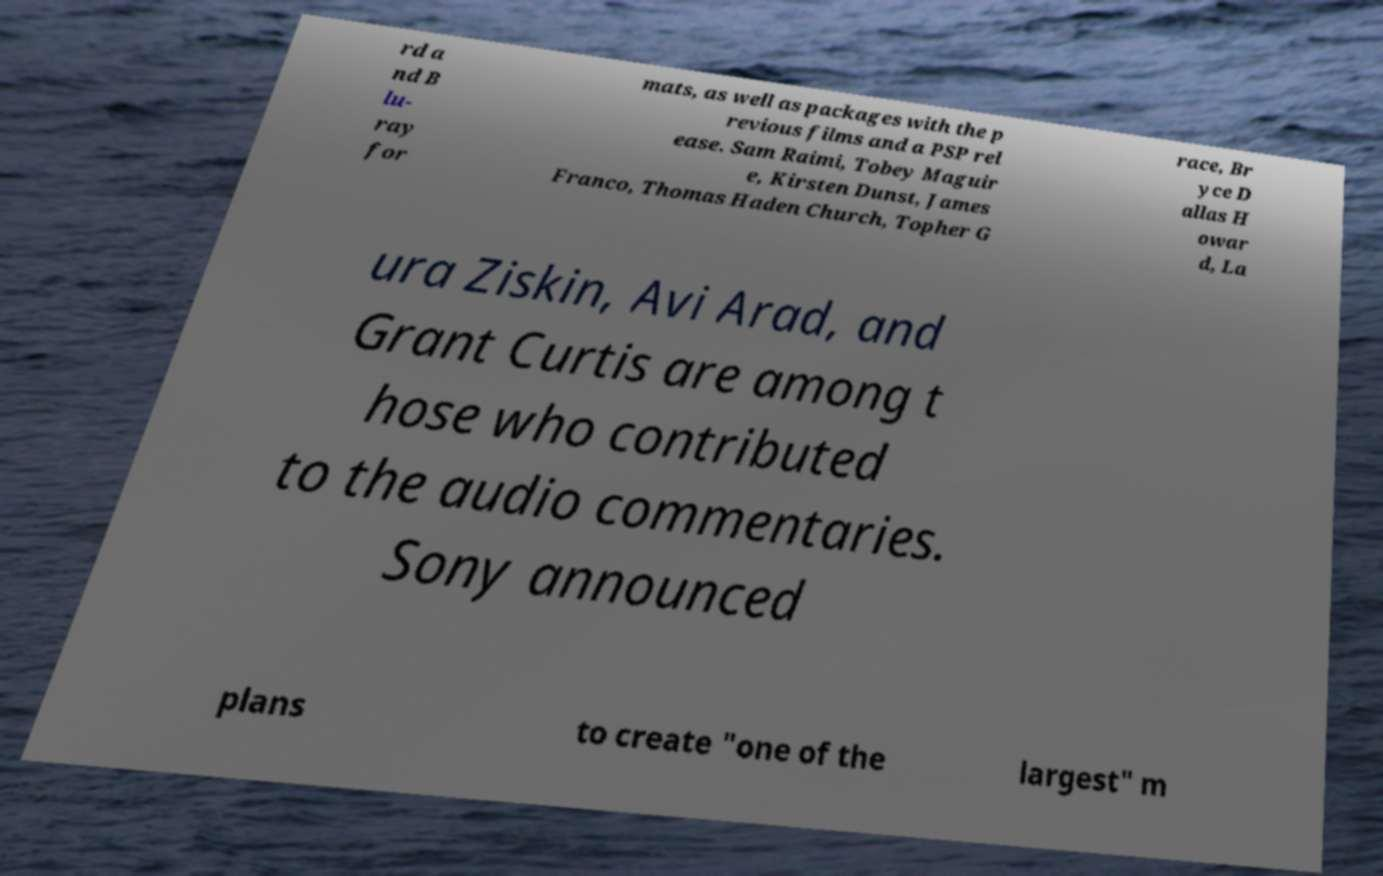Please read and relay the text visible in this image. What does it say? rd a nd B lu- ray for mats, as well as packages with the p revious films and a PSP rel ease. Sam Raimi, Tobey Maguir e, Kirsten Dunst, James Franco, Thomas Haden Church, Topher G race, Br yce D allas H owar d, La ura Ziskin, Avi Arad, and Grant Curtis are among t hose who contributed to the audio commentaries. Sony announced plans to create "one of the largest" m 